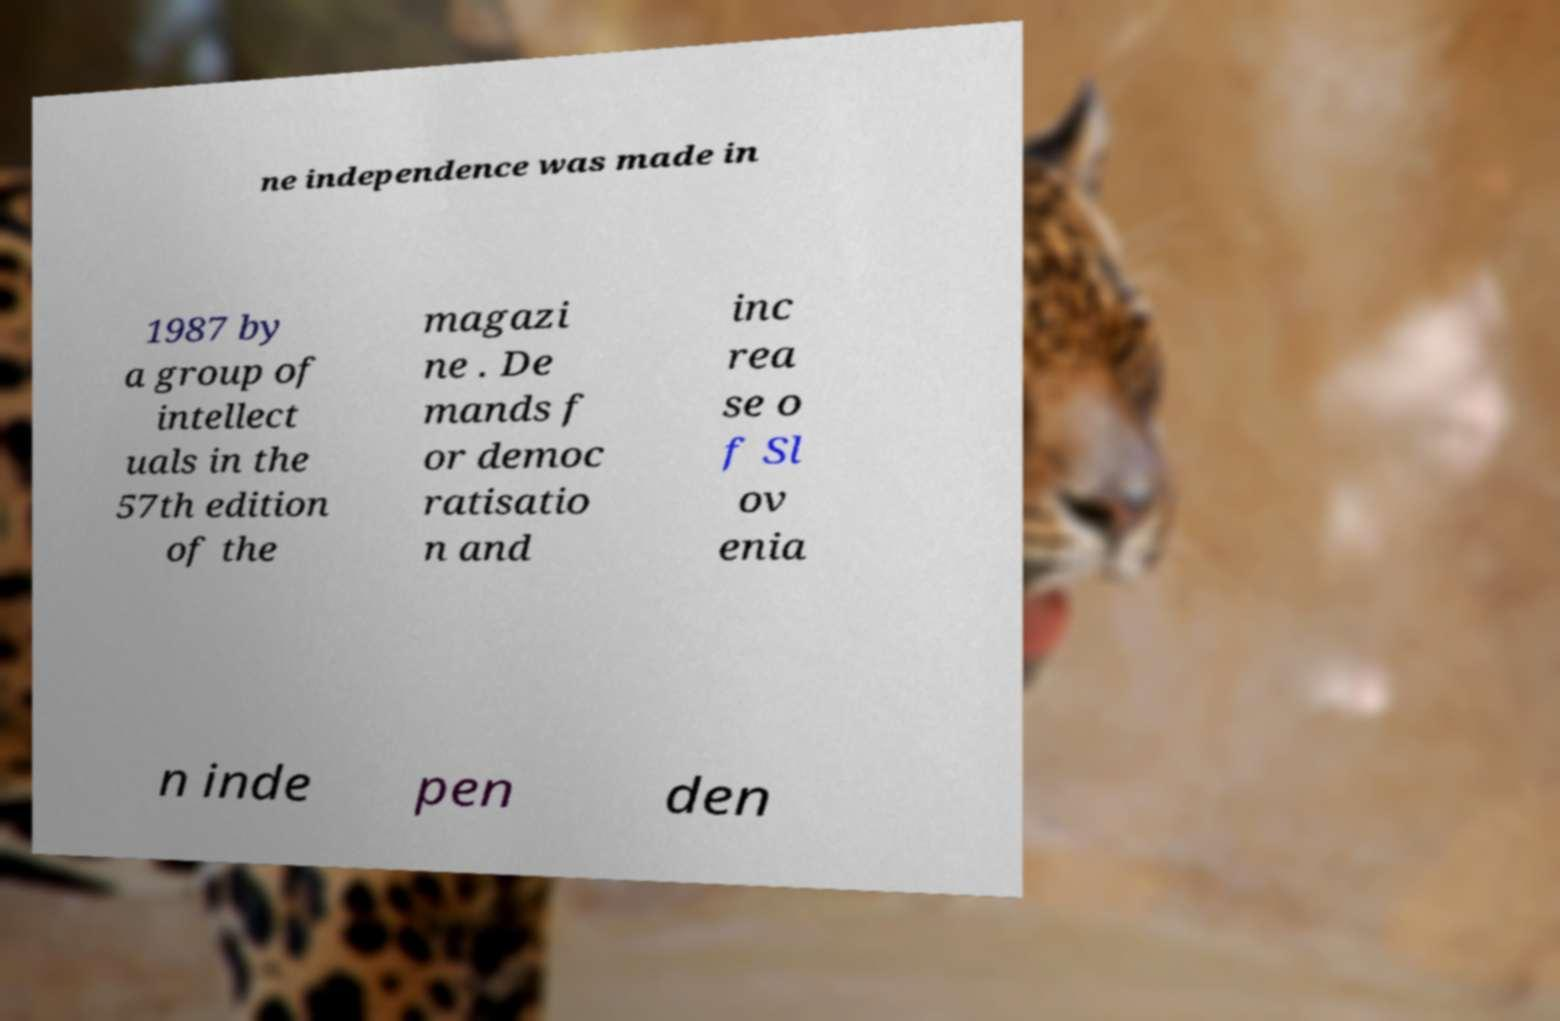Please read and relay the text visible in this image. What does it say? ne independence was made in 1987 by a group of intellect uals in the 57th edition of the magazi ne . De mands f or democ ratisatio n and inc rea se o f Sl ov enia n inde pen den 